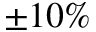Convert formula to latex. <formula><loc_0><loc_0><loc_500><loc_500>\pm 1 0 \%</formula> 